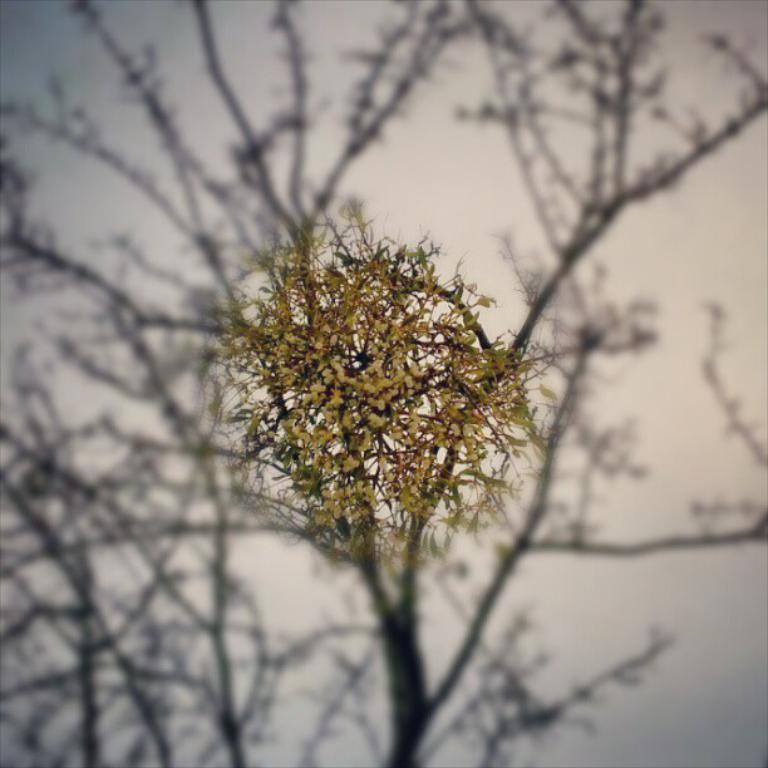What is the main subject of the image? There is a flower in the image. What is the property value of the flower in the image? There is no information about the property value of the flower in the image, as it is not relevant to the subject matter. 